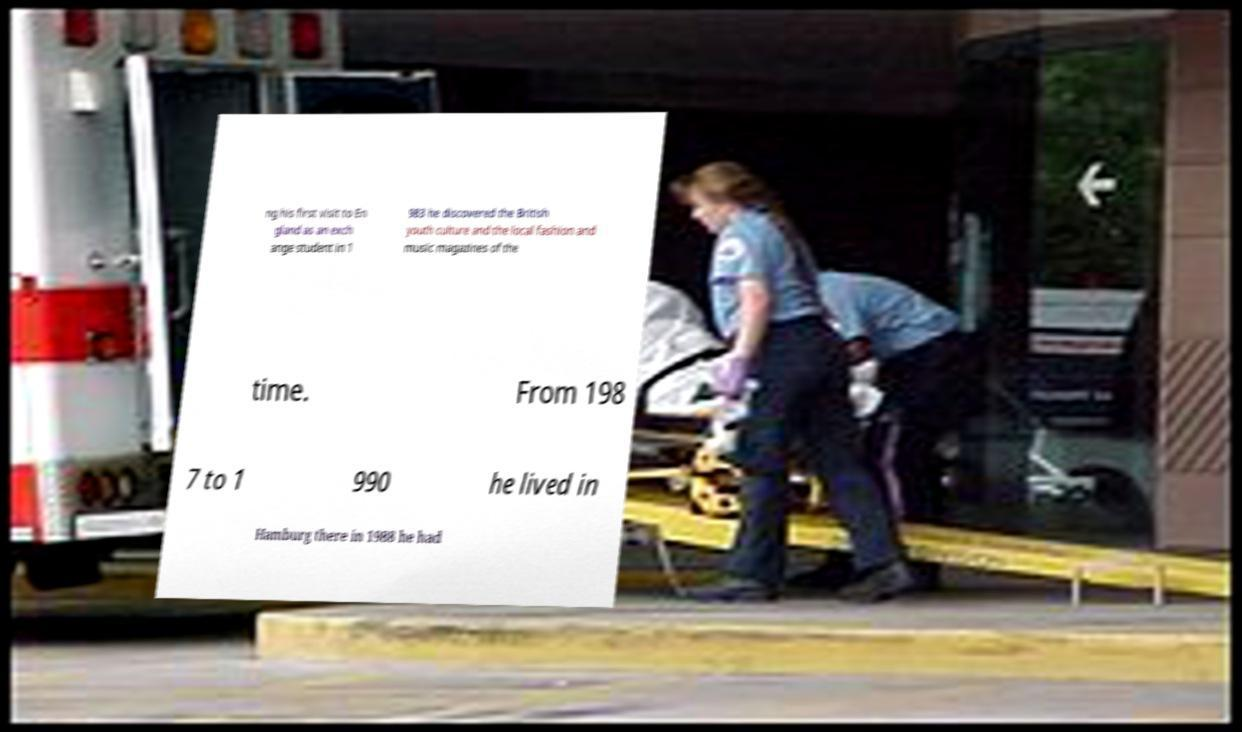Please read and relay the text visible in this image. What does it say? ng his first visit to En gland as an exch ange student in 1 983 he discovered the British youth culture and the local fashion and music magazines of the time. From 198 7 to 1 990 he lived in Hamburg there in 1988 he had 